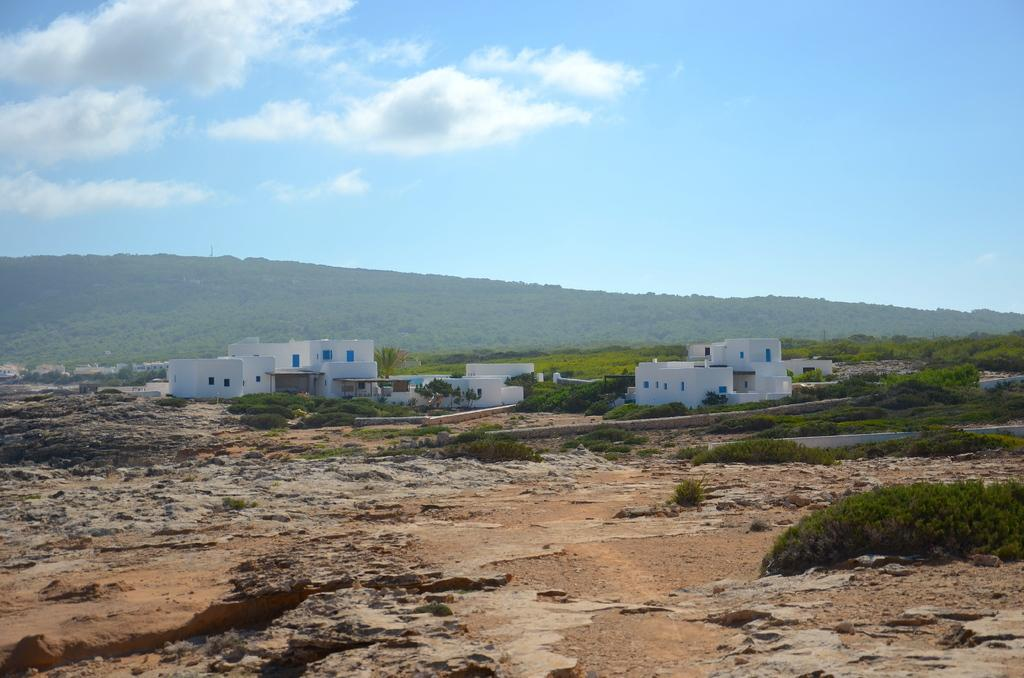What type of vegetation can be seen in the image? There are plants and trees in the image. What structures are visible in the background of the image? There are buildings with windows in the background. What natural feature can be seen in the background of the image? There is a hill in the background. What part of the natural environment is visible in the image? The sky is visible in the image. What can be observed in the sky in the image? Clouds are present in the sky. Where is the dad waiting for his flight in the image? There is no dad or airport present in the image. How does the lift help people move around in the image? There is no lift present in the image. 